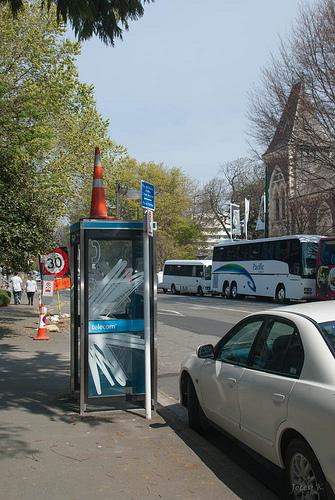Question: who is in the phone booth?
Choices:
A. A man.
B. A woman.
C. Empty.
D. A dog.
Answer with the letter. Answer: C Question: why are there orange cones?
Choices:
A. To block a pothole.
B. They are next to a work vehicle.
C. To close road.
D. There is a car accident.
Answer with the letter. Answer: C Question: what color are the cones?
Choices:
A. Black and orange.
B. White and yellow.
C. Orange and white.
D. Yellow and black.
Answer with the letter. Answer: C 